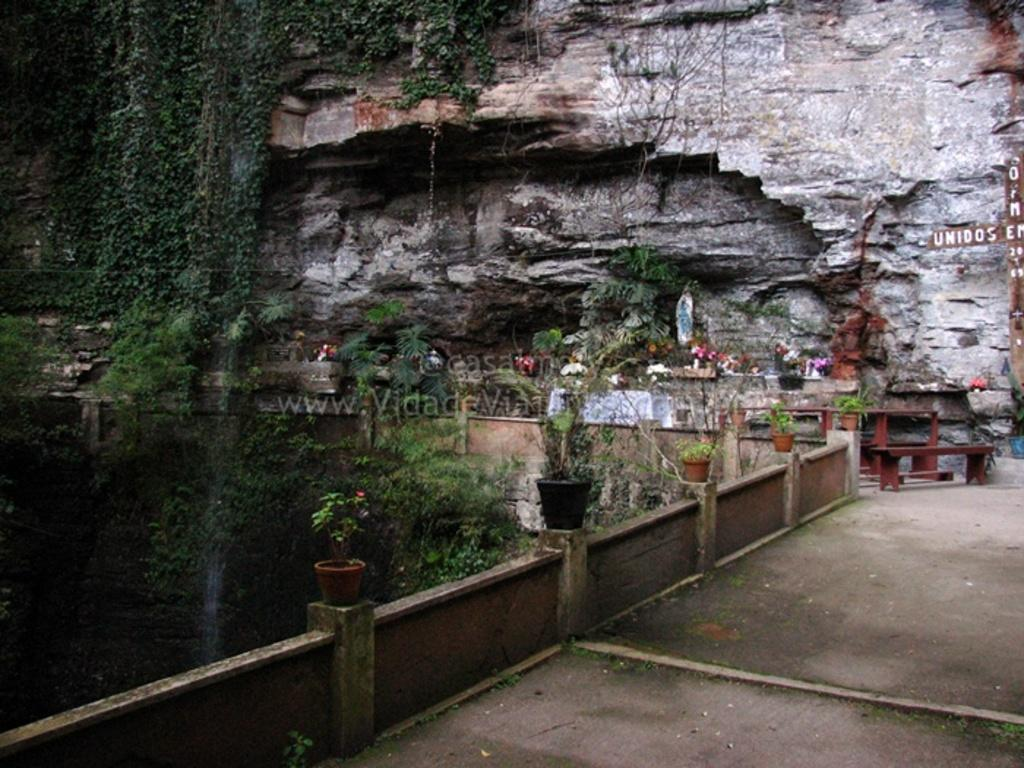What is attached to the wall in the image? Flower pots are placed on the wall in the image. What type of furniture can be seen in the image? There are tables in the image. What type of vegetation is present in the image? Trees and creepers are visible in the image. What can be seen in the background of the image? There is a stone wall in the background. What book is the person reading while sitting on the table in the image? There is no person or book present in the image; it features flower pots on the wall, tables, trees, creepers, and a stone wall in the background. How many tickets are visible in the image? There are no tickets present in the image. 